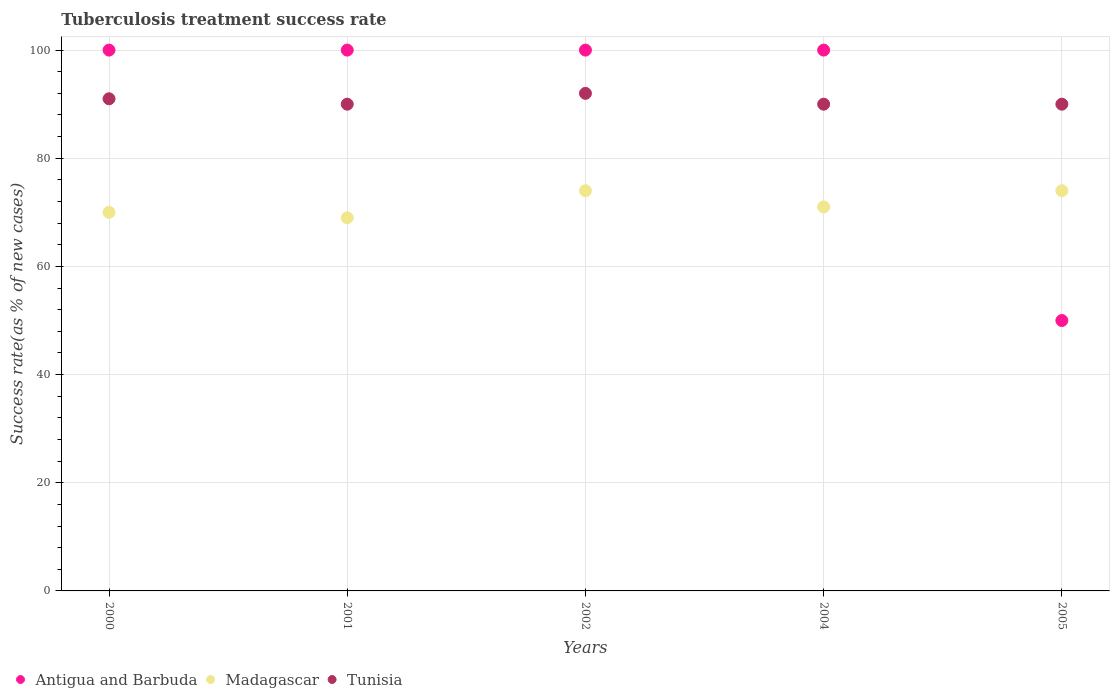How many different coloured dotlines are there?
Provide a short and direct response. 3. Across all years, what is the maximum tuberculosis treatment success rate in Tunisia?
Your answer should be compact. 92. In which year was the tuberculosis treatment success rate in Madagascar maximum?
Provide a short and direct response. 2002. In which year was the tuberculosis treatment success rate in Antigua and Barbuda minimum?
Your response must be concise. 2005. What is the total tuberculosis treatment success rate in Antigua and Barbuda in the graph?
Keep it short and to the point. 450. What is the average tuberculosis treatment success rate in Antigua and Barbuda per year?
Keep it short and to the point. 90. Is the tuberculosis treatment success rate in Tunisia in 2002 less than that in 2004?
Provide a succinct answer. No. Is the difference between the tuberculosis treatment success rate in Madagascar in 2002 and 2005 greater than the difference between the tuberculosis treatment success rate in Tunisia in 2002 and 2005?
Your response must be concise. No. What is the difference between the highest and the second highest tuberculosis treatment success rate in Tunisia?
Your answer should be compact. 1. In how many years, is the tuberculosis treatment success rate in Tunisia greater than the average tuberculosis treatment success rate in Tunisia taken over all years?
Offer a terse response. 2. Is it the case that in every year, the sum of the tuberculosis treatment success rate in Tunisia and tuberculosis treatment success rate in Madagascar  is greater than the tuberculosis treatment success rate in Antigua and Barbuda?
Your response must be concise. Yes. Is the tuberculosis treatment success rate in Antigua and Barbuda strictly greater than the tuberculosis treatment success rate in Tunisia over the years?
Offer a terse response. No. Is the tuberculosis treatment success rate in Madagascar strictly less than the tuberculosis treatment success rate in Tunisia over the years?
Provide a short and direct response. Yes. How many dotlines are there?
Provide a short and direct response. 3. Are the values on the major ticks of Y-axis written in scientific E-notation?
Provide a succinct answer. No. Does the graph contain any zero values?
Provide a short and direct response. No. Where does the legend appear in the graph?
Give a very brief answer. Bottom left. What is the title of the graph?
Keep it short and to the point. Tuberculosis treatment success rate. What is the label or title of the X-axis?
Provide a short and direct response. Years. What is the label or title of the Y-axis?
Provide a succinct answer. Success rate(as % of new cases). What is the Success rate(as % of new cases) in Madagascar in 2000?
Provide a succinct answer. 70. What is the Success rate(as % of new cases) of Tunisia in 2000?
Give a very brief answer. 91. What is the Success rate(as % of new cases) in Madagascar in 2001?
Keep it short and to the point. 69. What is the Success rate(as % of new cases) of Tunisia in 2001?
Ensure brevity in your answer.  90. What is the Success rate(as % of new cases) of Madagascar in 2002?
Give a very brief answer. 74. What is the Success rate(as % of new cases) of Tunisia in 2002?
Ensure brevity in your answer.  92. What is the Success rate(as % of new cases) of Antigua and Barbuda in 2004?
Provide a succinct answer. 100. What is the Success rate(as % of new cases) of Madagascar in 2004?
Give a very brief answer. 71. What is the Success rate(as % of new cases) in Antigua and Barbuda in 2005?
Offer a terse response. 50. Across all years, what is the maximum Success rate(as % of new cases) in Antigua and Barbuda?
Ensure brevity in your answer.  100. Across all years, what is the maximum Success rate(as % of new cases) in Madagascar?
Your answer should be very brief. 74. Across all years, what is the maximum Success rate(as % of new cases) in Tunisia?
Your answer should be very brief. 92. What is the total Success rate(as % of new cases) in Antigua and Barbuda in the graph?
Offer a very short reply. 450. What is the total Success rate(as % of new cases) of Madagascar in the graph?
Offer a terse response. 358. What is the total Success rate(as % of new cases) of Tunisia in the graph?
Provide a short and direct response. 453. What is the difference between the Success rate(as % of new cases) of Madagascar in 2000 and that in 2001?
Your answer should be very brief. 1. What is the difference between the Success rate(as % of new cases) in Antigua and Barbuda in 2000 and that in 2002?
Provide a succinct answer. 0. What is the difference between the Success rate(as % of new cases) in Tunisia in 2000 and that in 2002?
Keep it short and to the point. -1. What is the difference between the Success rate(as % of new cases) in Madagascar in 2000 and that in 2004?
Ensure brevity in your answer.  -1. What is the difference between the Success rate(as % of new cases) of Antigua and Barbuda in 2000 and that in 2005?
Provide a short and direct response. 50. What is the difference between the Success rate(as % of new cases) in Madagascar in 2001 and that in 2002?
Your answer should be compact. -5. What is the difference between the Success rate(as % of new cases) of Antigua and Barbuda in 2001 and that in 2004?
Give a very brief answer. 0. What is the difference between the Success rate(as % of new cases) in Tunisia in 2001 and that in 2004?
Keep it short and to the point. 0. What is the difference between the Success rate(as % of new cases) of Antigua and Barbuda in 2001 and that in 2005?
Provide a succinct answer. 50. What is the difference between the Success rate(as % of new cases) of Madagascar in 2001 and that in 2005?
Your answer should be compact. -5. What is the difference between the Success rate(as % of new cases) of Tunisia in 2001 and that in 2005?
Your response must be concise. 0. What is the difference between the Success rate(as % of new cases) in Antigua and Barbuda in 2002 and that in 2004?
Offer a very short reply. 0. What is the difference between the Success rate(as % of new cases) in Madagascar in 2002 and that in 2004?
Your answer should be very brief. 3. What is the difference between the Success rate(as % of new cases) in Madagascar in 2002 and that in 2005?
Offer a very short reply. 0. What is the difference between the Success rate(as % of new cases) in Tunisia in 2002 and that in 2005?
Ensure brevity in your answer.  2. What is the difference between the Success rate(as % of new cases) of Madagascar in 2004 and that in 2005?
Give a very brief answer. -3. What is the difference between the Success rate(as % of new cases) of Tunisia in 2004 and that in 2005?
Give a very brief answer. 0. What is the difference between the Success rate(as % of new cases) of Antigua and Barbuda in 2000 and the Success rate(as % of new cases) of Madagascar in 2001?
Your answer should be very brief. 31. What is the difference between the Success rate(as % of new cases) of Madagascar in 2000 and the Success rate(as % of new cases) of Tunisia in 2001?
Make the answer very short. -20. What is the difference between the Success rate(as % of new cases) of Antigua and Barbuda in 2000 and the Success rate(as % of new cases) of Madagascar in 2002?
Your answer should be very brief. 26. What is the difference between the Success rate(as % of new cases) of Antigua and Barbuda in 2000 and the Success rate(as % of new cases) of Tunisia in 2002?
Offer a very short reply. 8. What is the difference between the Success rate(as % of new cases) in Madagascar in 2000 and the Success rate(as % of new cases) in Tunisia in 2004?
Offer a terse response. -20. What is the difference between the Success rate(as % of new cases) in Antigua and Barbuda in 2000 and the Success rate(as % of new cases) in Madagascar in 2005?
Your answer should be compact. 26. What is the difference between the Success rate(as % of new cases) in Antigua and Barbuda in 2000 and the Success rate(as % of new cases) in Tunisia in 2005?
Your answer should be very brief. 10. What is the difference between the Success rate(as % of new cases) in Madagascar in 2000 and the Success rate(as % of new cases) in Tunisia in 2005?
Your answer should be compact. -20. What is the difference between the Success rate(as % of new cases) in Antigua and Barbuda in 2001 and the Success rate(as % of new cases) in Madagascar in 2002?
Give a very brief answer. 26. What is the difference between the Success rate(as % of new cases) in Antigua and Barbuda in 2001 and the Success rate(as % of new cases) in Tunisia in 2002?
Your response must be concise. 8. What is the difference between the Success rate(as % of new cases) of Antigua and Barbuda in 2001 and the Success rate(as % of new cases) of Madagascar in 2004?
Ensure brevity in your answer.  29. What is the difference between the Success rate(as % of new cases) of Antigua and Barbuda in 2001 and the Success rate(as % of new cases) of Tunisia in 2004?
Offer a very short reply. 10. What is the difference between the Success rate(as % of new cases) in Antigua and Barbuda in 2001 and the Success rate(as % of new cases) in Madagascar in 2005?
Provide a short and direct response. 26. What is the difference between the Success rate(as % of new cases) of Antigua and Barbuda in 2001 and the Success rate(as % of new cases) of Tunisia in 2005?
Keep it short and to the point. 10. What is the difference between the Success rate(as % of new cases) in Madagascar in 2002 and the Success rate(as % of new cases) in Tunisia in 2004?
Your answer should be compact. -16. What is the difference between the Success rate(as % of new cases) of Antigua and Barbuda in 2002 and the Success rate(as % of new cases) of Madagascar in 2005?
Give a very brief answer. 26. What is the difference between the Success rate(as % of new cases) of Madagascar in 2002 and the Success rate(as % of new cases) of Tunisia in 2005?
Ensure brevity in your answer.  -16. What is the average Success rate(as % of new cases) of Antigua and Barbuda per year?
Your answer should be very brief. 90. What is the average Success rate(as % of new cases) in Madagascar per year?
Provide a short and direct response. 71.6. What is the average Success rate(as % of new cases) of Tunisia per year?
Keep it short and to the point. 90.6. In the year 2001, what is the difference between the Success rate(as % of new cases) in Antigua and Barbuda and Success rate(as % of new cases) in Madagascar?
Provide a succinct answer. 31. In the year 2002, what is the difference between the Success rate(as % of new cases) of Antigua and Barbuda and Success rate(as % of new cases) of Madagascar?
Provide a short and direct response. 26. In the year 2002, what is the difference between the Success rate(as % of new cases) of Madagascar and Success rate(as % of new cases) of Tunisia?
Provide a succinct answer. -18. In the year 2004, what is the difference between the Success rate(as % of new cases) of Antigua and Barbuda and Success rate(as % of new cases) of Madagascar?
Your answer should be compact. 29. In the year 2004, what is the difference between the Success rate(as % of new cases) in Antigua and Barbuda and Success rate(as % of new cases) in Tunisia?
Provide a succinct answer. 10. In the year 2004, what is the difference between the Success rate(as % of new cases) in Madagascar and Success rate(as % of new cases) in Tunisia?
Offer a very short reply. -19. In the year 2005, what is the difference between the Success rate(as % of new cases) of Madagascar and Success rate(as % of new cases) of Tunisia?
Your answer should be compact. -16. What is the ratio of the Success rate(as % of new cases) in Madagascar in 2000 to that in 2001?
Your response must be concise. 1.01. What is the ratio of the Success rate(as % of new cases) in Tunisia in 2000 to that in 2001?
Provide a short and direct response. 1.01. What is the ratio of the Success rate(as % of new cases) of Antigua and Barbuda in 2000 to that in 2002?
Make the answer very short. 1. What is the ratio of the Success rate(as % of new cases) in Madagascar in 2000 to that in 2002?
Provide a short and direct response. 0.95. What is the ratio of the Success rate(as % of new cases) of Antigua and Barbuda in 2000 to that in 2004?
Provide a succinct answer. 1. What is the ratio of the Success rate(as % of new cases) of Madagascar in 2000 to that in 2004?
Your response must be concise. 0.99. What is the ratio of the Success rate(as % of new cases) of Tunisia in 2000 to that in 2004?
Keep it short and to the point. 1.01. What is the ratio of the Success rate(as % of new cases) of Antigua and Barbuda in 2000 to that in 2005?
Ensure brevity in your answer.  2. What is the ratio of the Success rate(as % of new cases) in Madagascar in 2000 to that in 2005?
Give a very brief answer. 0.95. What is the ratio of the Success rate(as % of new cases) of Tunisia in 2000 to that in 2005?
Give a very brief answer. 1.01. What is the ratio of the Success rate(as % of new cases) in Antigua and Barbuda in 2001 to that in 2002?
Offer a terse response. 1. What is the ratio of the Success rate(as % of new cases) in Madagascar in 2001 to that in 2002?
Give a very brief answer. 0.93. What is the ratio of the Success rate(as % of new cases) of Tunisia in 2001 to that in 2002?
Your response must be concise. 0.98. What is the ratio of the Success rate(as % of new cases) in Madagascar in 2001 to that in 2004?
Make the answer very short. 0.97. What is the ratio of the Success rate(as % of new cases) in Tunisia in 2001 to that in 2004?
Give a very brief answer. 1. What is the ratio of the Success rate(as % of new cases) of Madagascar in 2001 to that in 2005?
Offer a very short reply. 0.93. What is the ratio of the Success rate(as % of new cases) of Tunisia in 2001 to that in 2005?
Provide a short and direct response. 1. What is the ratio of the Success rate(as % of new cases) in Madagascar in 2002 to that in 2004?
Your response must be concise. 1.04. What is the ratio of the Success rate(as % of new cases) of Tunisia in 2002 to that in 2004?
Provide a short and direct response. 1.02. What is the ratio of the Success rate(as % of new cases) of Antigua and Barbuda in 2002 to that in 2005?
Offer a very short reply. 2. What is the ratio of the Success rate(as % of new cases) in Madagascar in 2002 to that in 2005?
Offer a very short reply. 1. What is the ratio of the Success rate(as % of new cases) in Tunisia in 2002 to that in 2005?
Your response must be concise. 1.02. What is the ratio of the Success rate(as % of new cases) of Antigua and Barbuda in 2004 to that in 2005?
Ensure brevity in your answer.  2. What is the ratio of the Success rate(as % of new cases) of Madagascar in 2004 to that in 2005?
Give a very brief answer. 0.96. What is the difference between the highest and the second highest Success rate(as % of new cases) in Antigua and Barbuda?
Keep it short and to the point. 0. What is the difference between the highest and the lowest Success rate(as % of new cases) of Antigua and Barbuda?
Make the answer very short. 50. What is the difference between the highest and the lowest Success rate(as % of new cases) in Madagascar?
Provide a short and direct response. 5. 